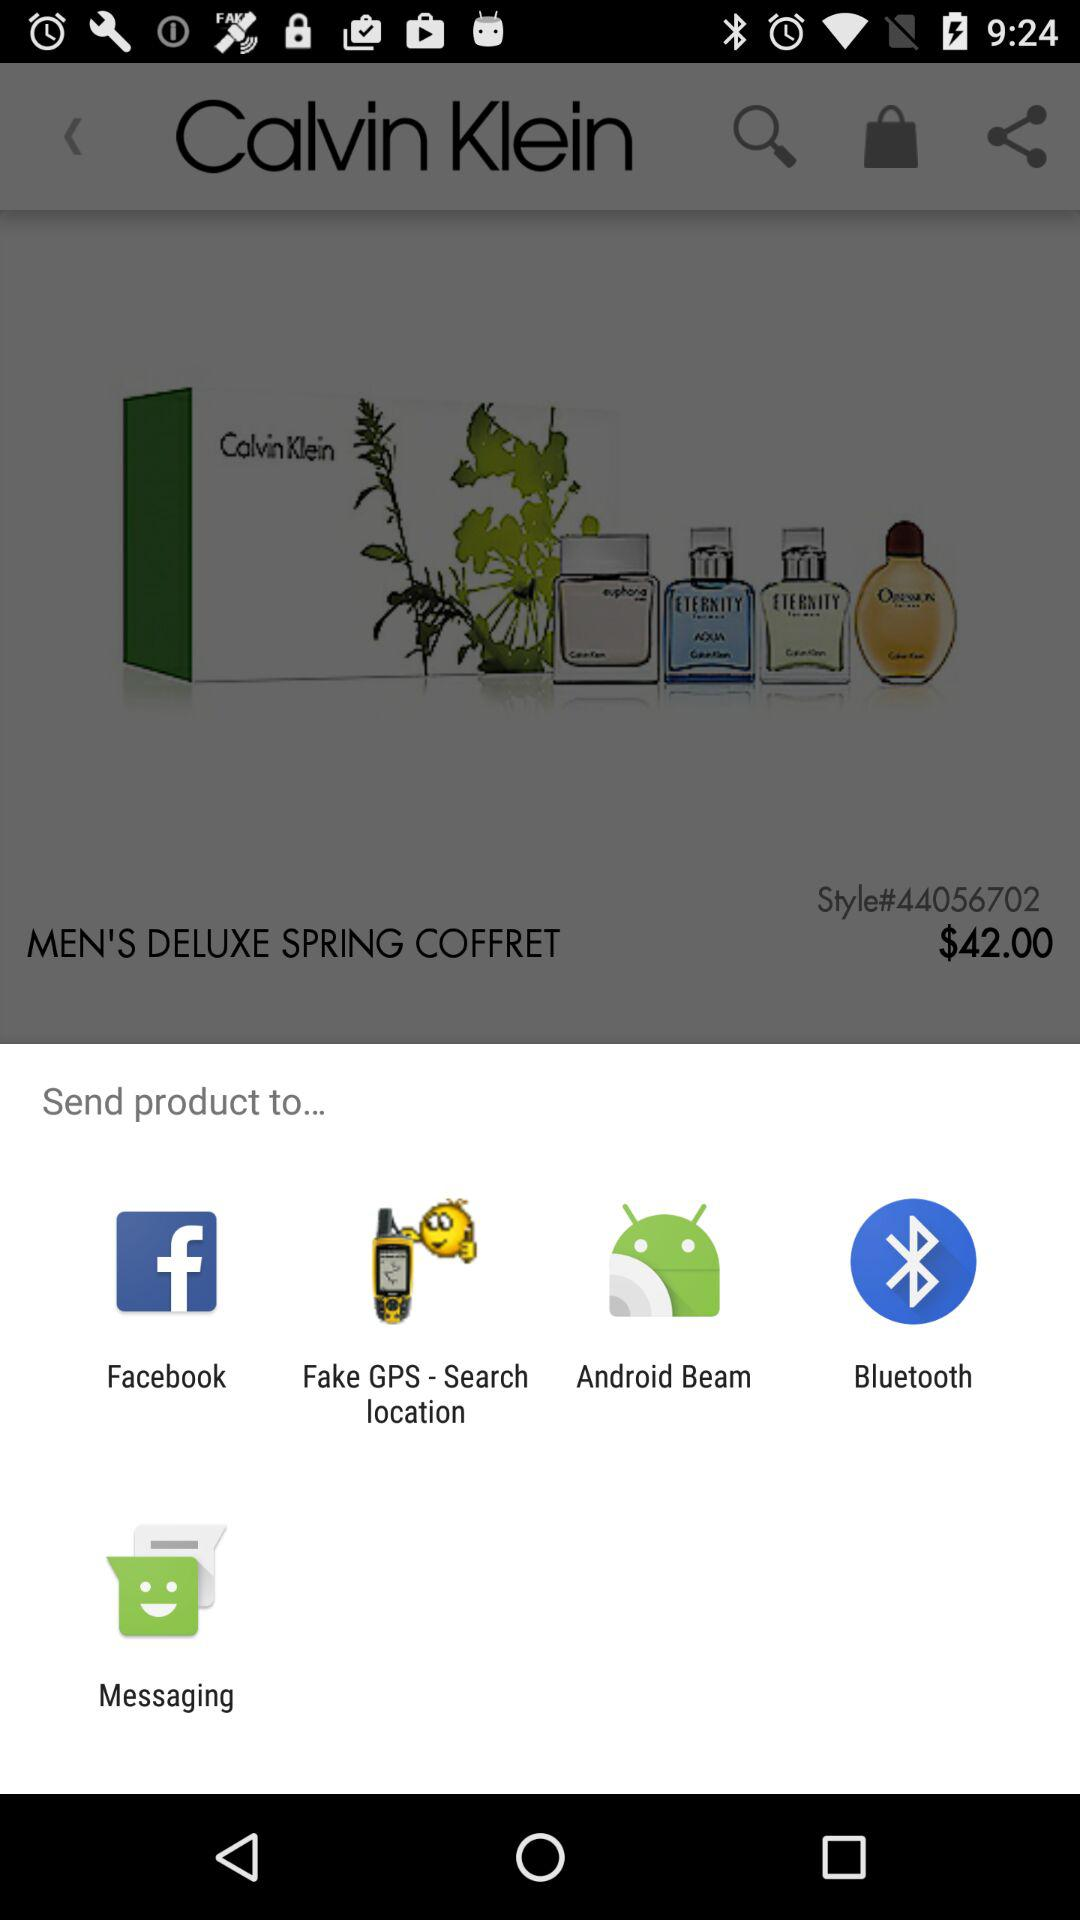What is the price of the item?
Answer the question using a single word or phrase. $42.00 